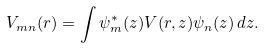Convert formula to latex. <formula><loc_0><loc_0><loc_500><loc_500>V _ { m n } ( r ) = \int \psi _ { m } ^ { * } ( z ) V ( r , z ) \psi _ { n } ( z ) \, d z .</formula> 